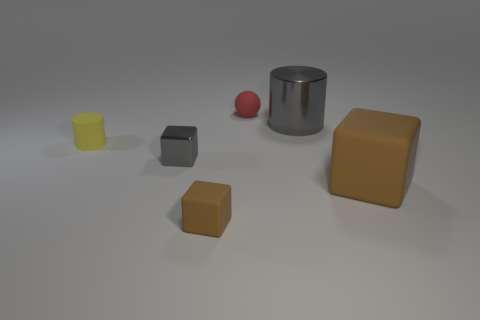Is there a gray object? yes 